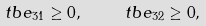<formula> <loc_0><loc_0><loc_500><loc_500>\ t b e _ { 3 1 } \geq 0 , \quad \ t b e _ { 3 2 } \geq 0 ,</formula> 